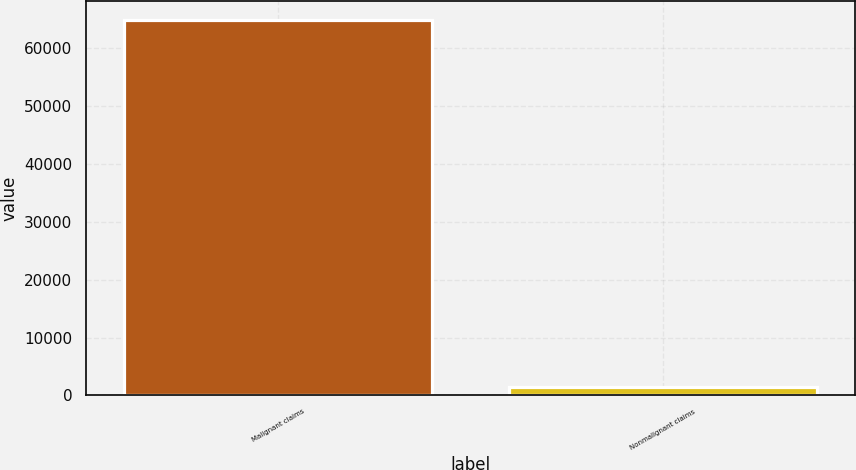Convert chart to OTSL. <chart><loc_0><loc_0><loc_500><loc_500><bar_chart><fcel>Malignant claims<fcel>Nonmalignant claims<nl><fcel>65000<fcel>1500<nl></chart> 